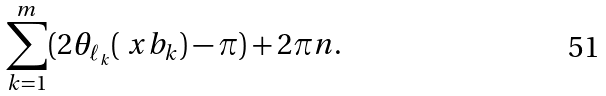<formula> <loc_0><loc_0><loc_500><loc_500>\sum _ { k = 1 } ^ { m } ( 2 \theta _ { \ell _ { k } } ( \ x b _ { k } ) - \pi ) + 2 \pi n .</formula> 